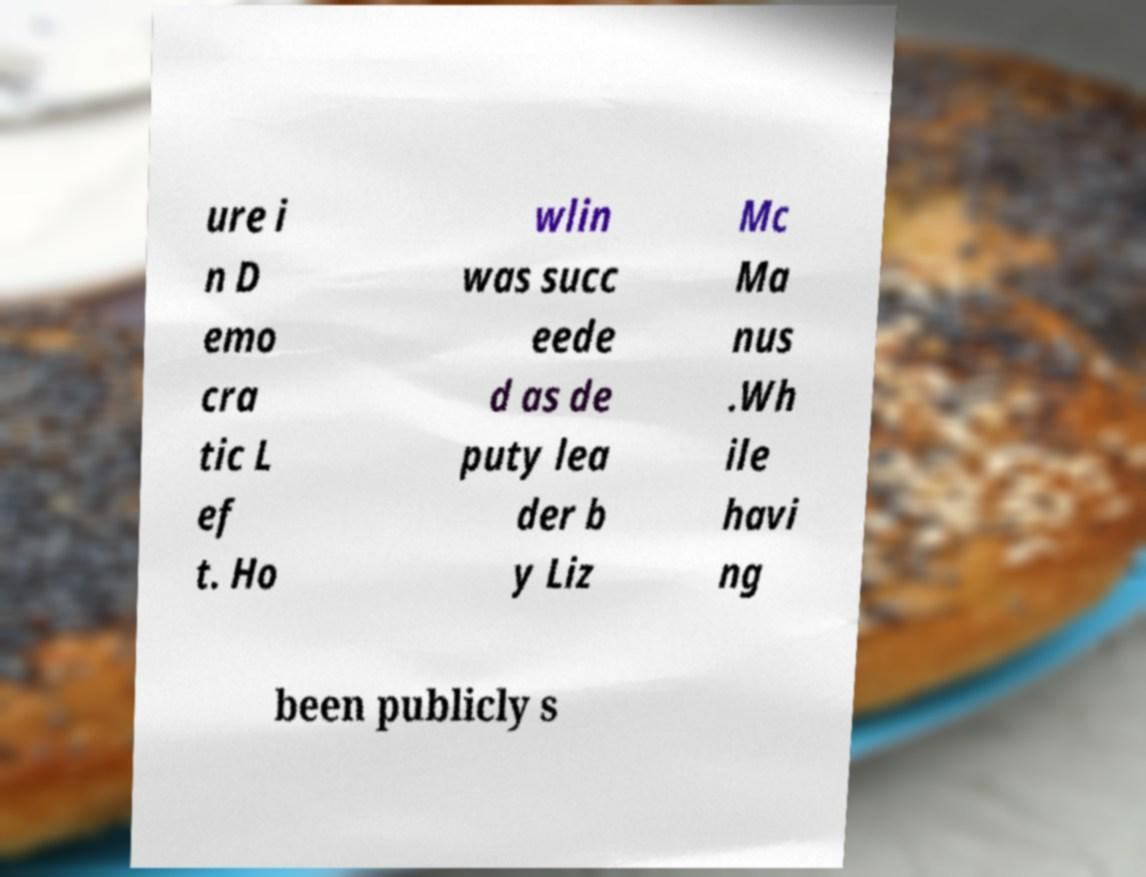What messages or text are displayed in this image? I need them in a readable, typed format. ure i n D emo cra tic L ef t. Ho wlin was succ eede d as de puty lea der b y Liz Mc Ma nus .Wh ile havi ng been publicly s 